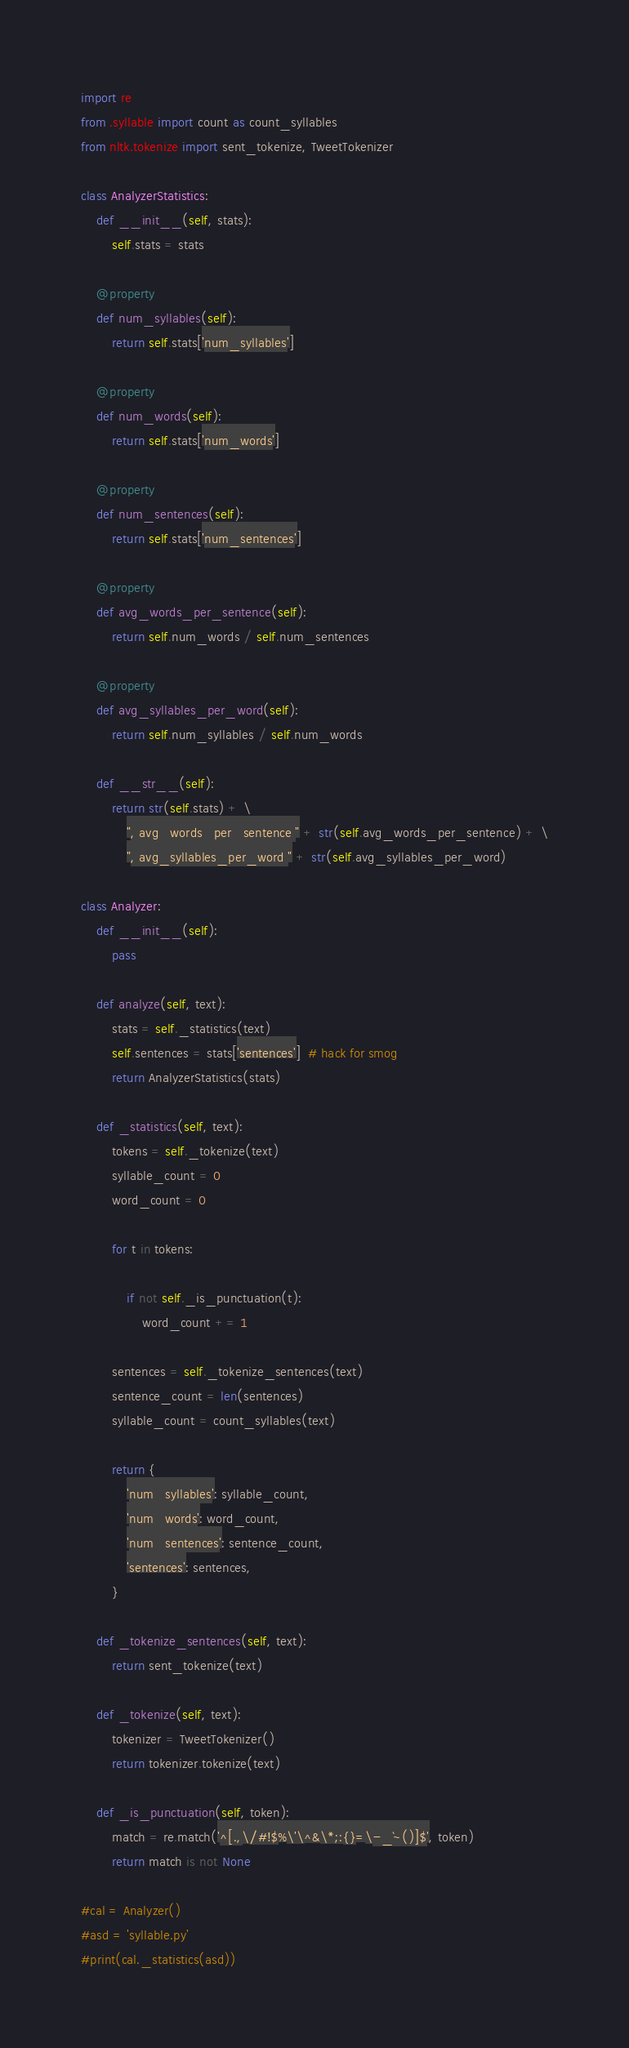<code> <loc_0><loc_0><loc_500><loc_500><_Python_>import re
from .syllable import count as count_syllables
from nltk.tokenize import sent_tokenize, TweetTokenizer

class AnalyzerStatistics:
    def __init__(self, stats):
        self.stats = stats

    @property
    def num_syllables(self):
        return self.stats['num_syllables']

    @property
    def num_words(self):
        return self.stats['num_words']

    @property
    def num_sentences(self):
        return self.stats['num_sentences']

    @property
    def avg_words_per_sentence(self):
        return self.num_words / self.num_sentences

    @property
    def avg_syllables_per_word(self):
        return self.num_syllables / self.num_words

    def __str__(self):
        return str(self.stats) + \
            ", avg_words_per_sentence " + str(self.avg_words_per_sentence) + \
            ", avg_syllables_per_word " + str(self.avg_syllables_per_word)

class Analyzer:
    def __init__(self):
        pass

    def analyze(self, text):
        stats = self._statistics(text)
        self.sentences = stats['sentences']  # hack for smog
        return AnalyzerStatistics(stats)

    def _statistics(self, text):
        tokens = self._tokenize(text)
        syllable_count = 0
        word_count = 0

        for t in tokens:

            if not self._is_punctuation(t):
                word_count += 1

        sentences = self._tokenize_sentences(text)
        sentence_count = len(sentences)
        syllable_count = count_syllables(text)

        return {
            'num_syllables': syllable_count,
            'num_words': word_count,
            'num_sentences': sentence_count,
            'sentences': sentences,
        }

    def _tokenize_sentences(self, text):
        return sent_tokenize(text)

    def _tokenize(self, text):
        tokenizer = TweetTokenizer()
        return tokenizer.tokenize(text)

    def _is_punctuation(self, token):
        match = re.match('^[.,\/#!$%\'\^&\*;:{}=\-_`~()]$', token)
        return match is not None

#cal = Analyzer()
#asd = 'syllable.py'
#print(cal._statistics(asd))
</code> 